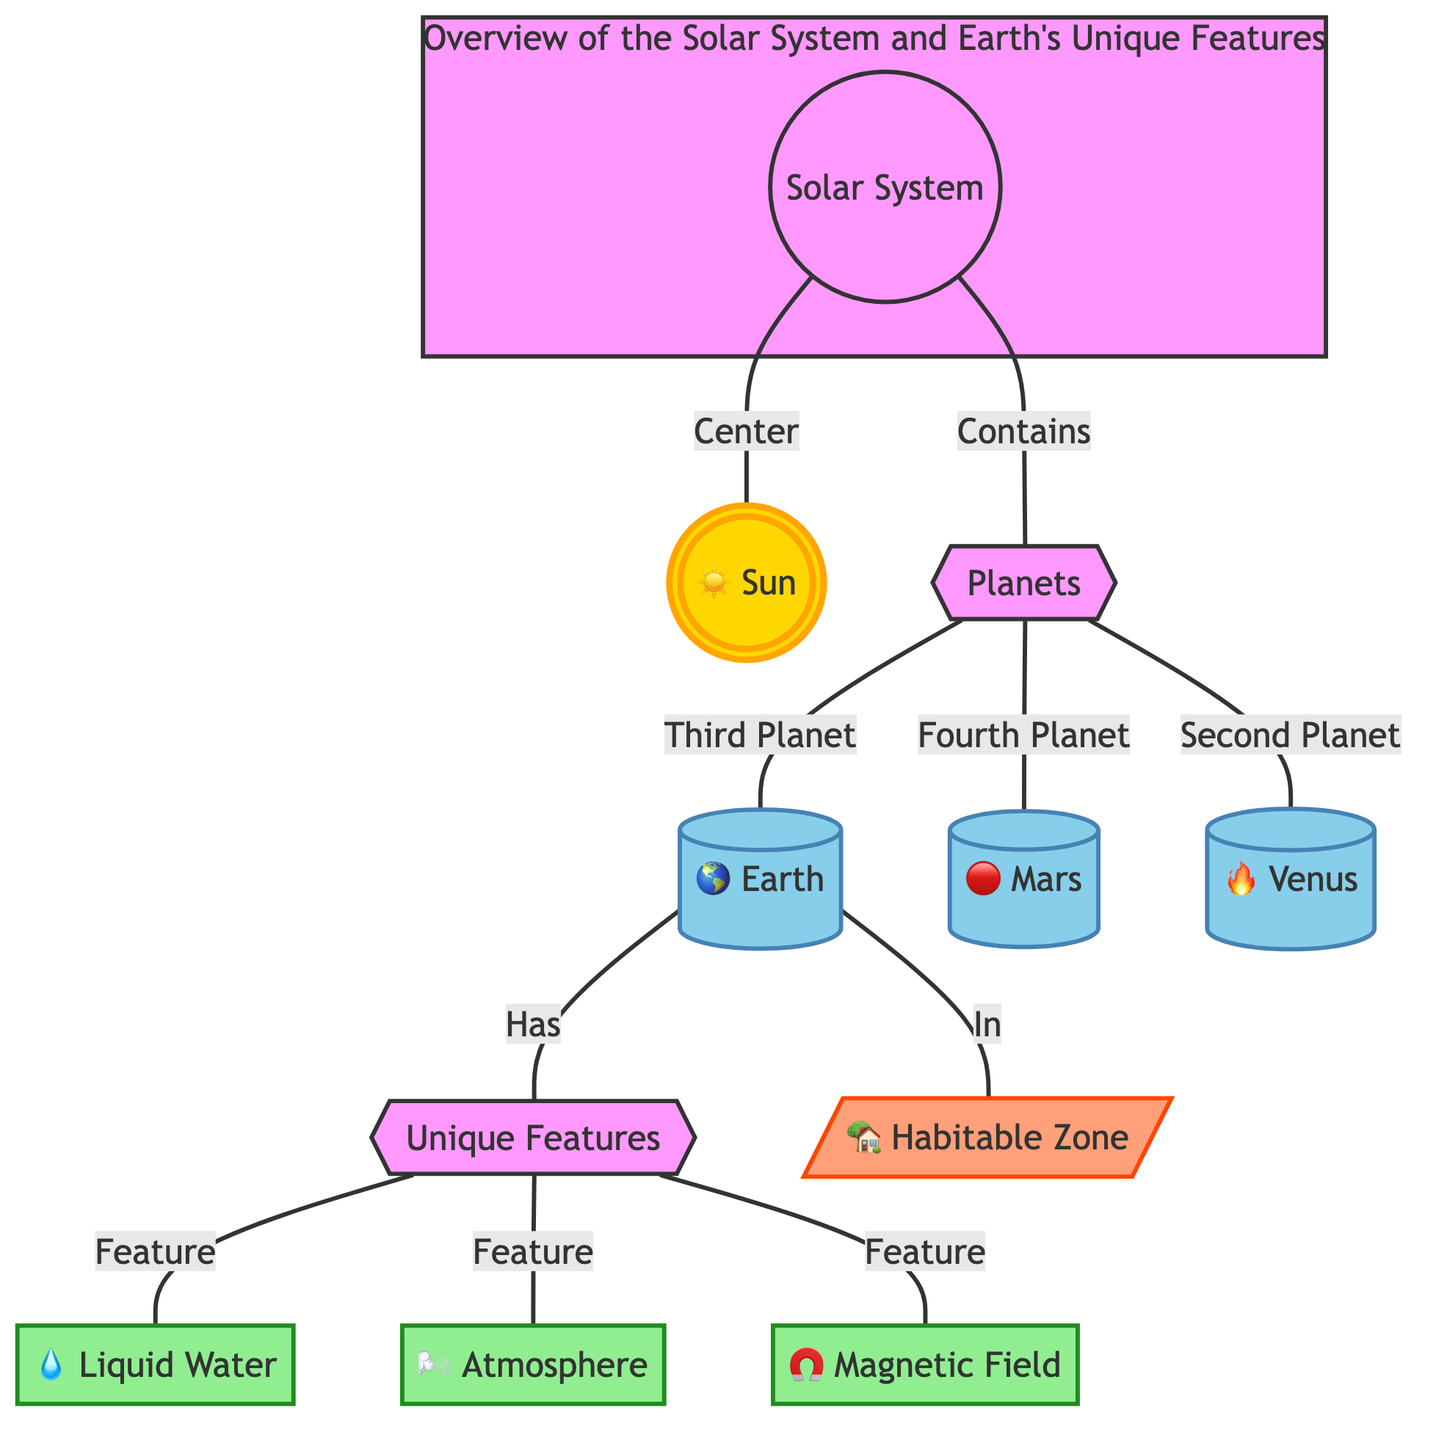What is the center of the Solar System? The diagram indicates that the Sun is at the center, denoted by the node labeled "Sun."
Answer: Sun How many planets are identified in the diagram? The diagram shows three planets, which are Earth, Mars, and Venus, as represented in the "Planets" node.
Answer: 3 What are the unique features of Earth? The diagram highlights three unique features associated with Earth: Liquid Water, Atmosphere, and Magnetic Field. These are depicted as connected to the Earth node under "Unique Features."
Answer: Water, Atmosphere, Magnetic Field Which planet is located in the habitable zone? The diagram specifically shows that Earth is the planet that is indicated as being "In" the habitable zone, which is represented in the corresponding node.
Answer: Earth Which planet is referred to as the "Fourth Planet"? The diagram explicitly states that Mars is categorized as the "Fourth Planet," connected to the "Planets" node.
Answer: Mars What features are listed for the habitable zone? The diagram does not list any features specifically for the habitable zone itself, as it primarily highlights Earth and its unique features. Therefore, the answer is that there are no features listed for the habitable zone in the diagram.
Answer: None How many unique features are connected to Earth? The diagram shows three unique features (Liquid Water, Atmosphere, Magnetic Field) connected specifically to Earth by the "Has" relationship.
Answer: 3 What color is the node for Mars? In the diagram, the node representing Mars is colored to represent planets, specifically denoted as a light blue shade attributed to the class definition for planets.
Answer: Light Blue Which node represents the relationship between Earth and unique features? The diagram utilizes the "Has" relationship to connect the Earth node to the unique features node, indicating the specific characteristics associated with Earth.
Answer: Has 